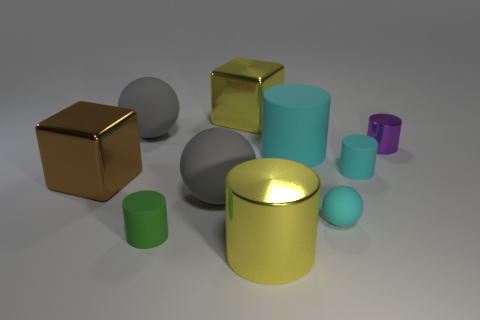How many objects are there in total, and can you classify them by color and shape? In total, there are ten objects. They can be classified as follows: two green cylinders, one golden cube, one golden cylinder, one blue sphere, two gray spheres, one purple cylinder, one teal cylinder, and one bronze cube. 